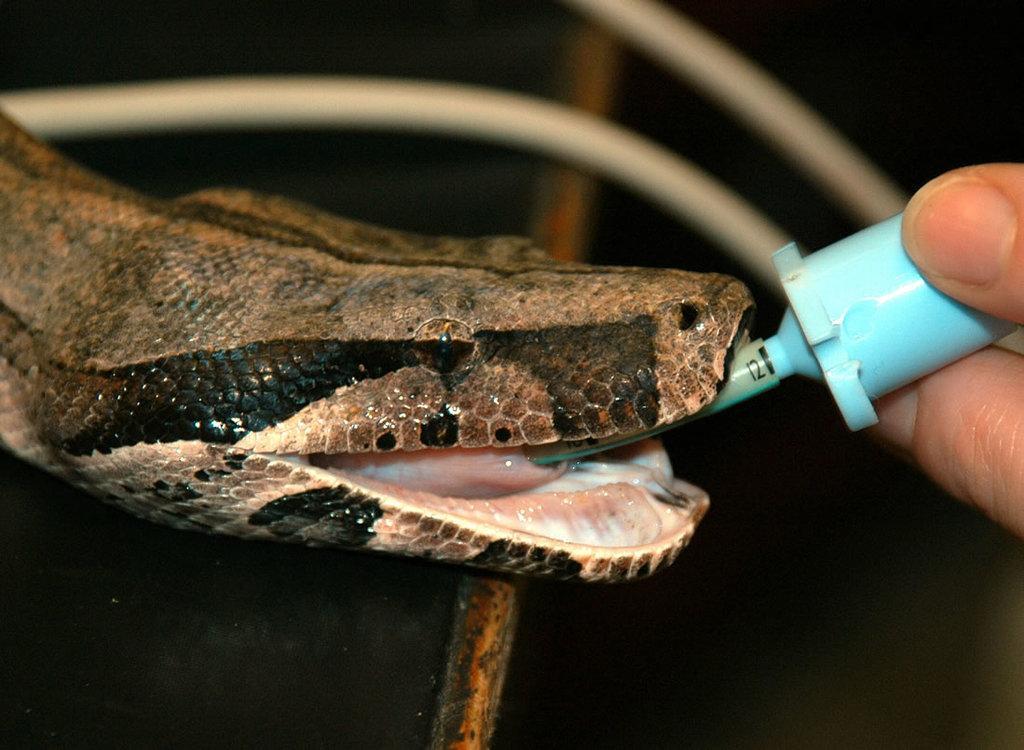In one or two sentences, can you explain what this image depicts? In this image, we can see a snake. There are fingers on the right side of the image holding an object. In the background, image is blurred. 